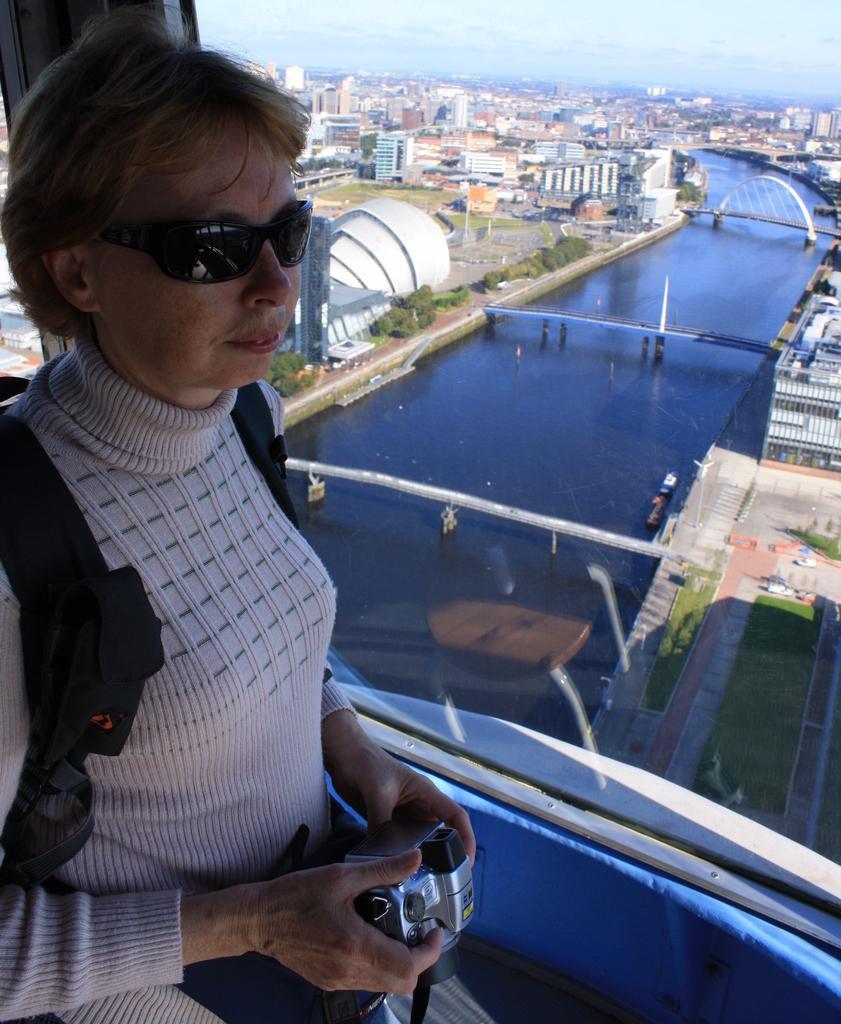Please provide a concise description of this image. On the left side of the image there is a woman wearing a bag, goggles, holding a camera in the hands and facing towards the right side. On the right side there is a glass through which we can see the outside view. In the outside there is a sea, three bridges, many trees and buildings. At the top of the image I can see the sky. 